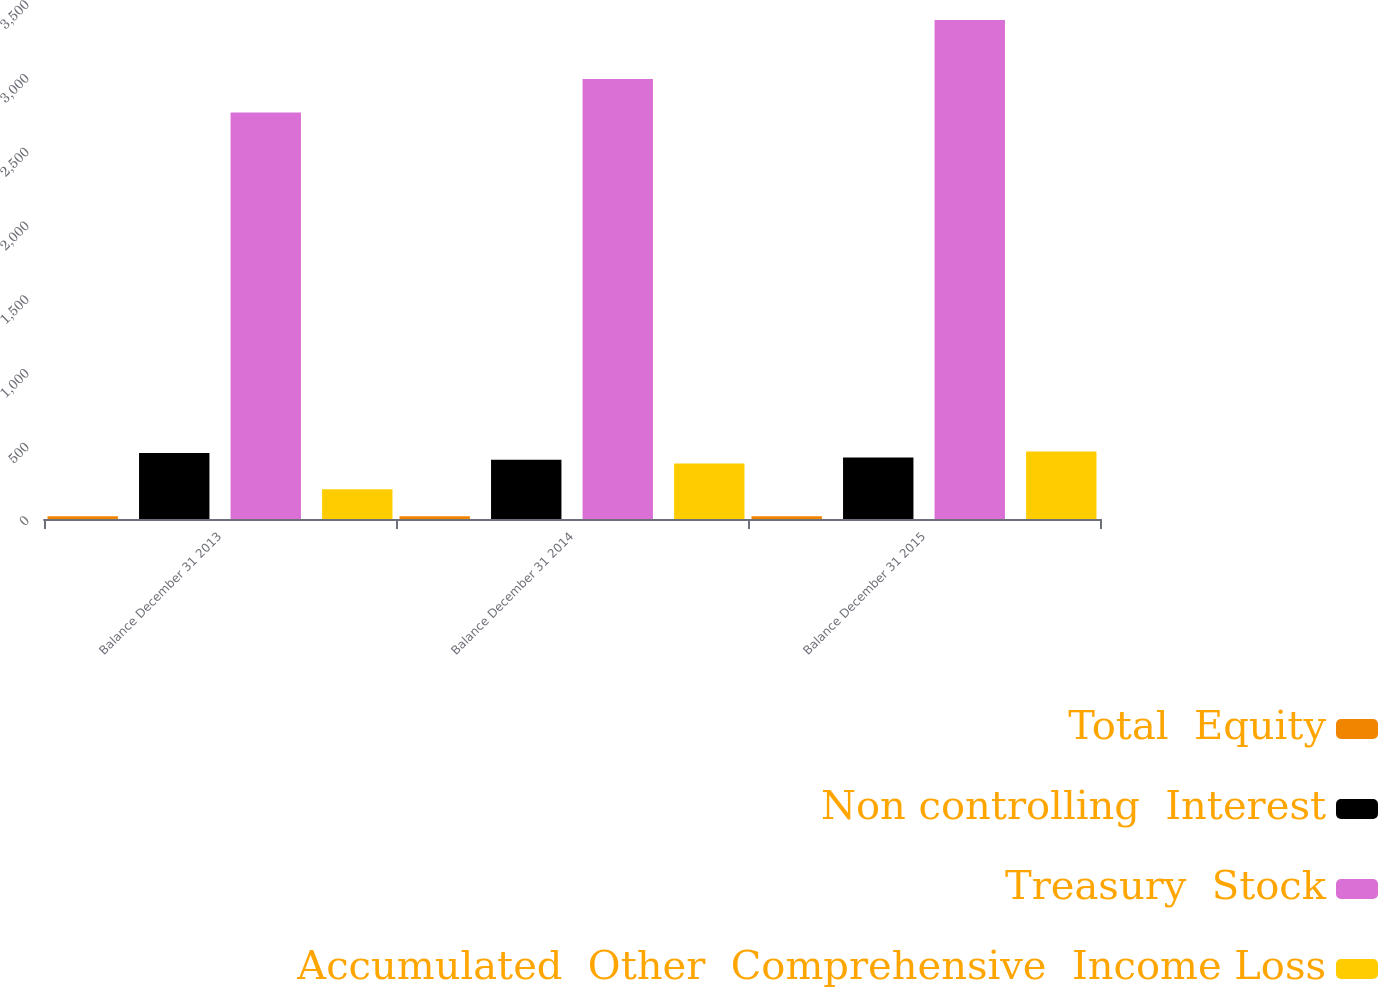<chart> <loc_0><loc_0><loc_500><loc_500><stacked_bar_chart><ecel><fcel>Balance December 31 2013<fcel>Balance December 31 2014<fcel>Balance December 31 2015<nl><fcel>Total  Equity<fcel>18.6<fcel>18.6<fcel>18.6<nl><fcel>Non controlling  Interest<fcel>448.3<fcel>401.9<fcel>417.7<nl><fcel>Treasury  Stock<fcel>2757.3<fcel>2984.5<fcel>3385<nl><fcel>Accumulated  Other  Comprehensive  Income Loss<fcel>201.9<fcel>375.8<fcel>457.3<nl></chart> 